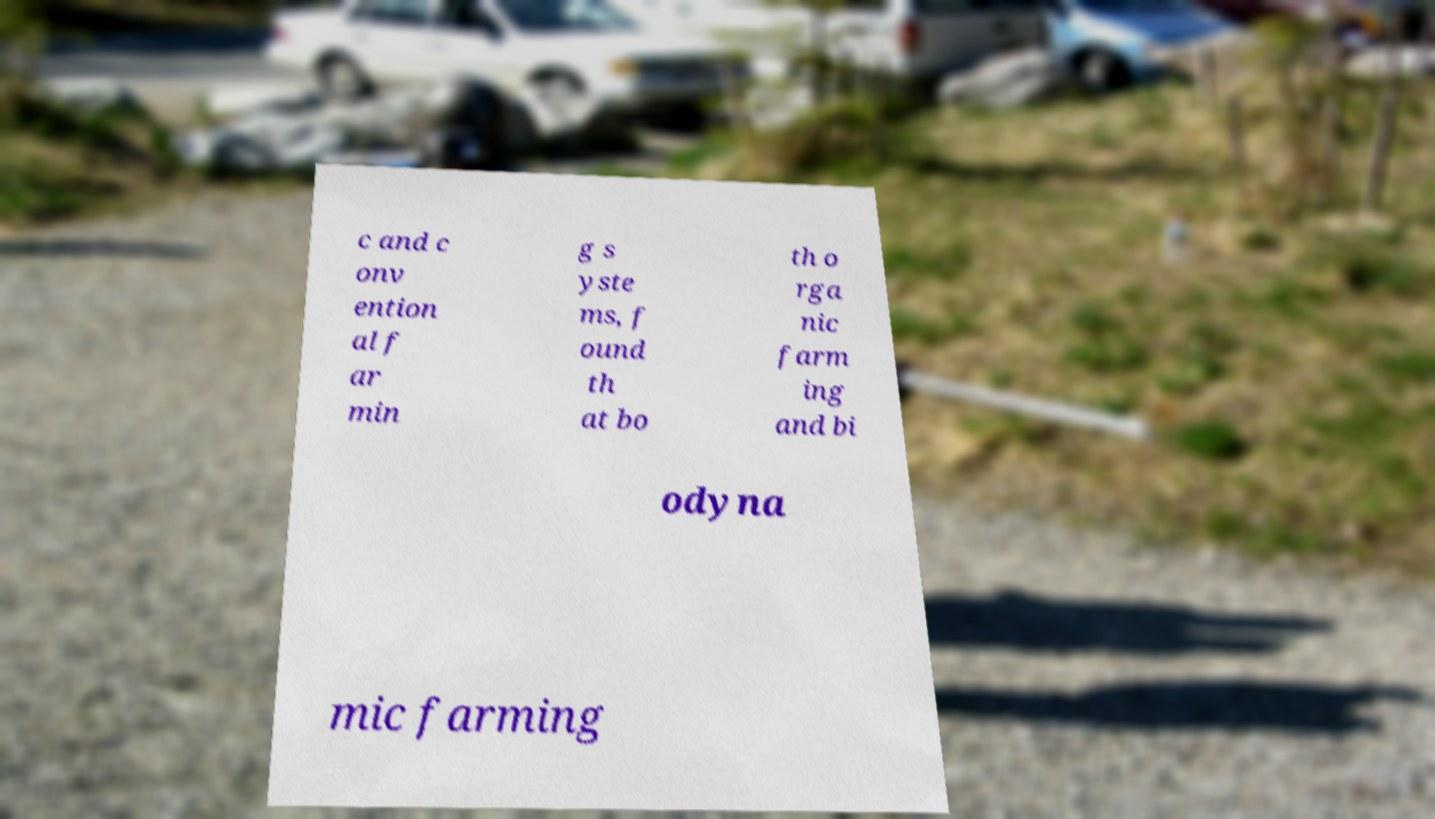Can you accurately transcribe the text from the provided image for me? c and c onv ention al f ar min g s yste ms, f ound th at bo th o rga nic farm ing and bi odyna mic farming 